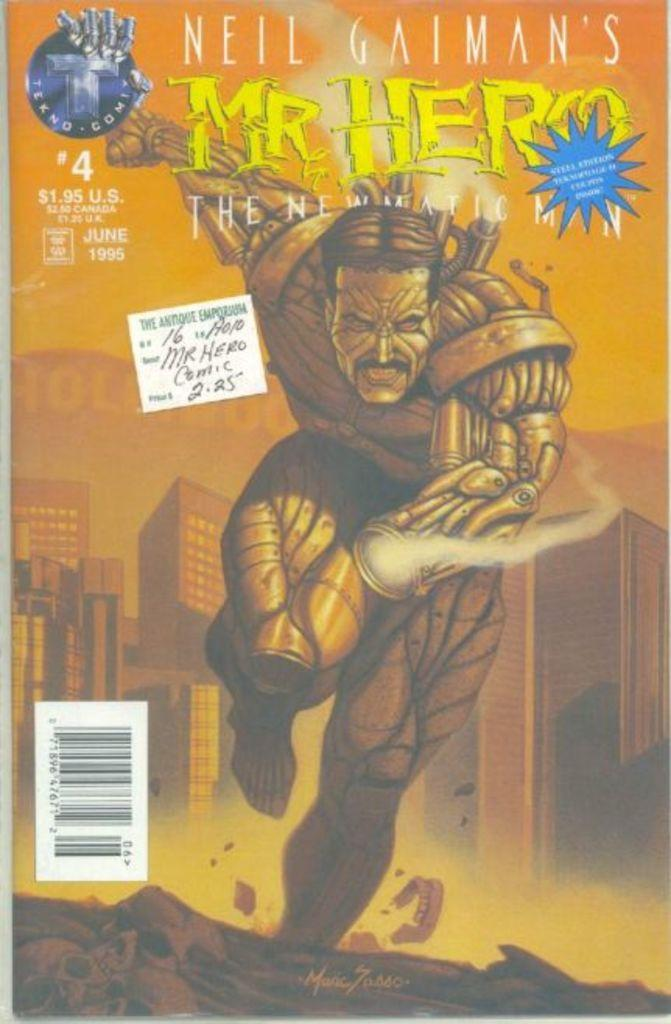<image>
Share a concise interpretation of the image provided. Comic book cover showing a superhero and the name "Neil Gaimans" on top. 